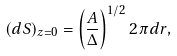<formula> <loc_0><loc_0><loc_500><loc_500>( d S ) _ { z = 0 } = \left ( \frac { A } { \Delta } \right ) ^ { 1 / 2 } 2 \pi d r ,</formula> 